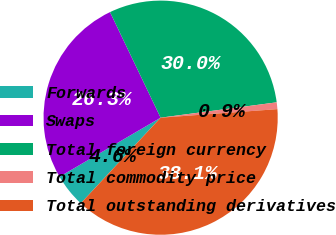<chart> <loc_0><loc_0><loc_500><loc_500><pie_chart><fcel>Forwards<fcel>Swaps<fcel>Total foreign currency<fcel>Total commodity price<fcel>Total outstanding derivatives<nl><fcel>4.64%<fcel>26.3%<fcel>30.02%<fcel>0.93%<fcel>38.11%<nl></chart> 